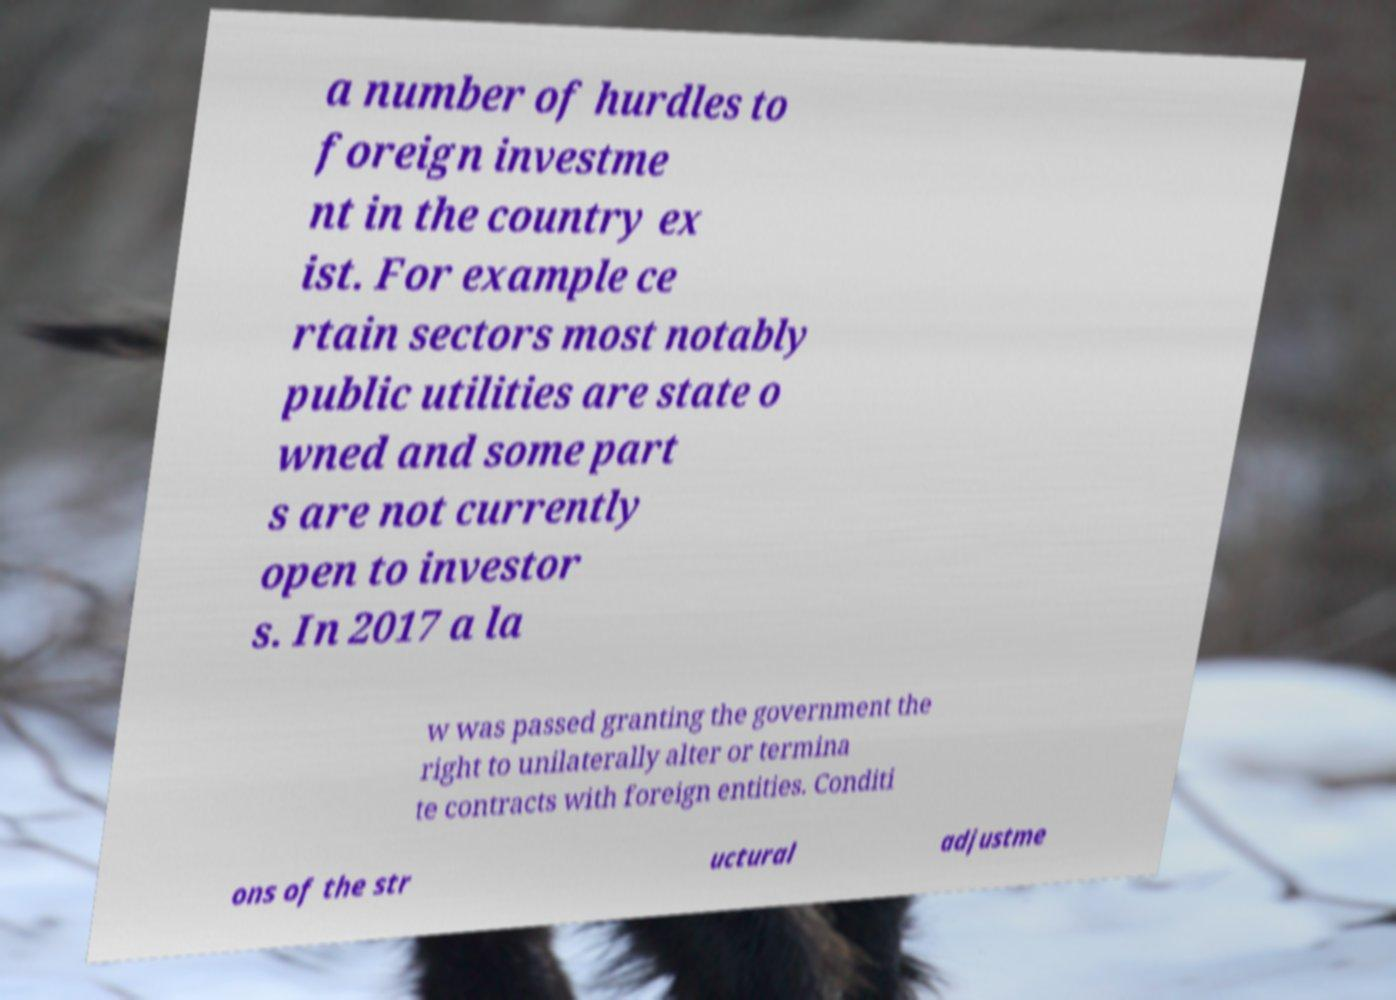I need the written content from this picture converted into text. Can you do that? a number of hurdles to foreign investme nt in the country ex ist. For example ce rtain sectors most notably public utilities are state o wned and some part s are not currently open to investor s. In 2017 a la w was passed granting the government the right to unilaterally alter or termina te contracts with foreign entities. Conditi ons of the str uctural adjustme 